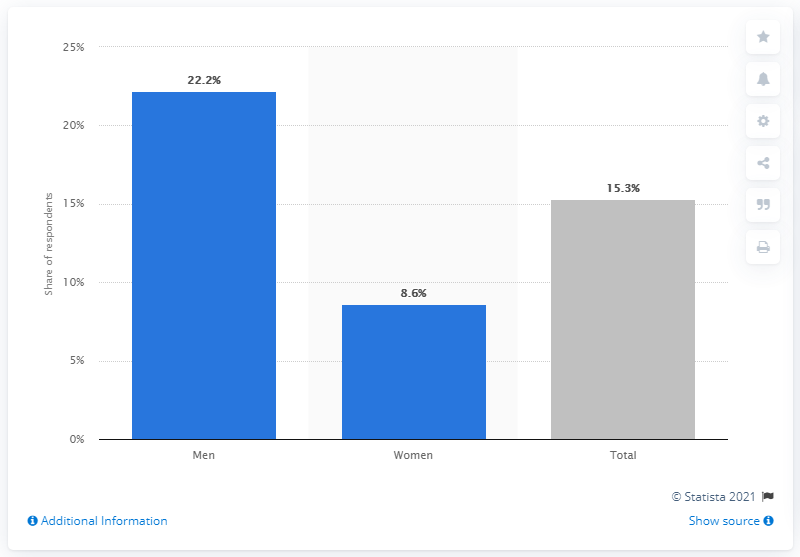Indicate a few pertinent items in this graphic. According to a recent study, 22.2% of men in Denmark have searched for sexual partners on the internet. A recent study found that 22.2% of women who used the internet for sexual purposes searched for partners online. 